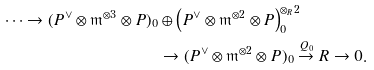<formula> <loc_0><loc_0><loc_500><loc_500>\cdots \to ( P ^ { \vee } \otimes \mathfrak { m } ^ { \otimes 3 } \otimes P ) _ { 0 } & \oplus \left ( P ^ { \vee } \otimes \mathfrak { m } ^ { \otimes 2 } \otimes P \right ) ^ { \otimes _ { R } 2 } _ { 0 } \\ & \to ( P ^ { \vee } \otimes \mathfrak { m } ^ { \otimes 2 } \otimes P ) _ { 0 } \stackrel { Q _ { 0 } } { \to } { R } \to 0 .</formula> 